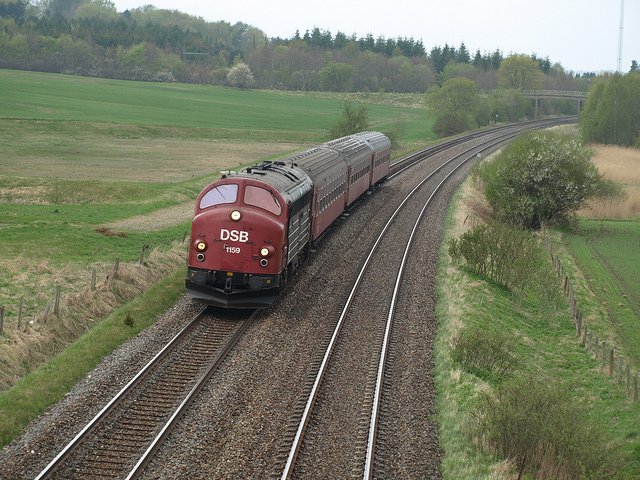How many sinks are there? The question seems to be unrelated to the image content. The image depicts a train moving along a curved section of railroad track in a rural setting, and there are no sinks visible. 